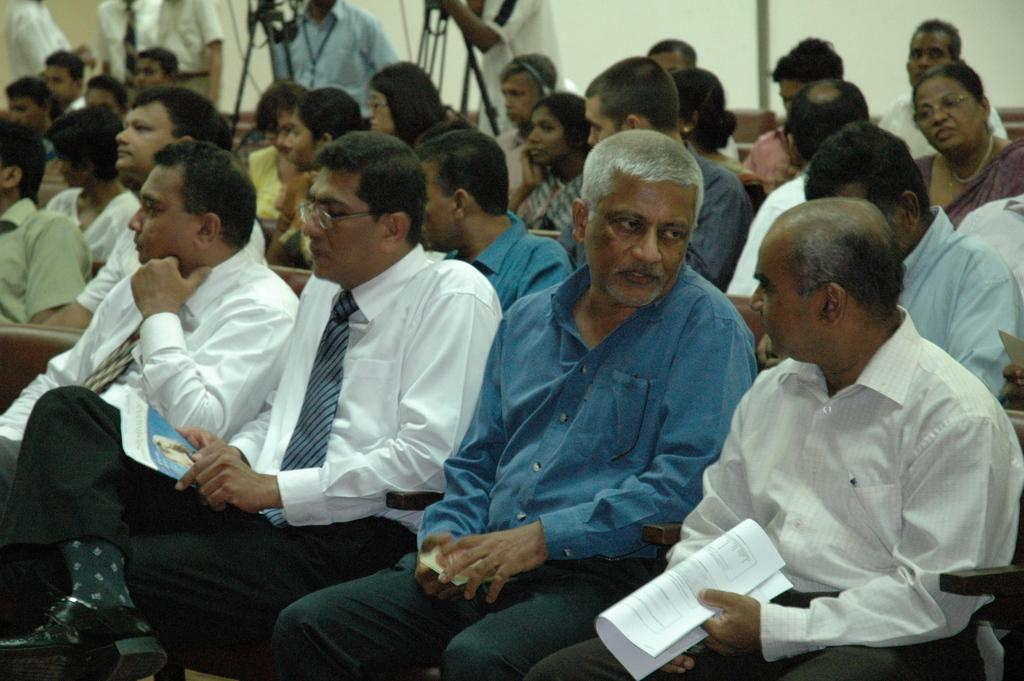What are the people in the middle of the image doing? The people in the middle of the image are sitting on chairs. What are the people behind the sitting people doing? The people behind the sitting people are holding cameras. What can be seen in the top right side of the image? There is a wall visible in the top right side of the image. What type of fiction is being read by the people sitting on chairs in the image? There is no indication in the image that the people are reading fiction or any other type of literature. 